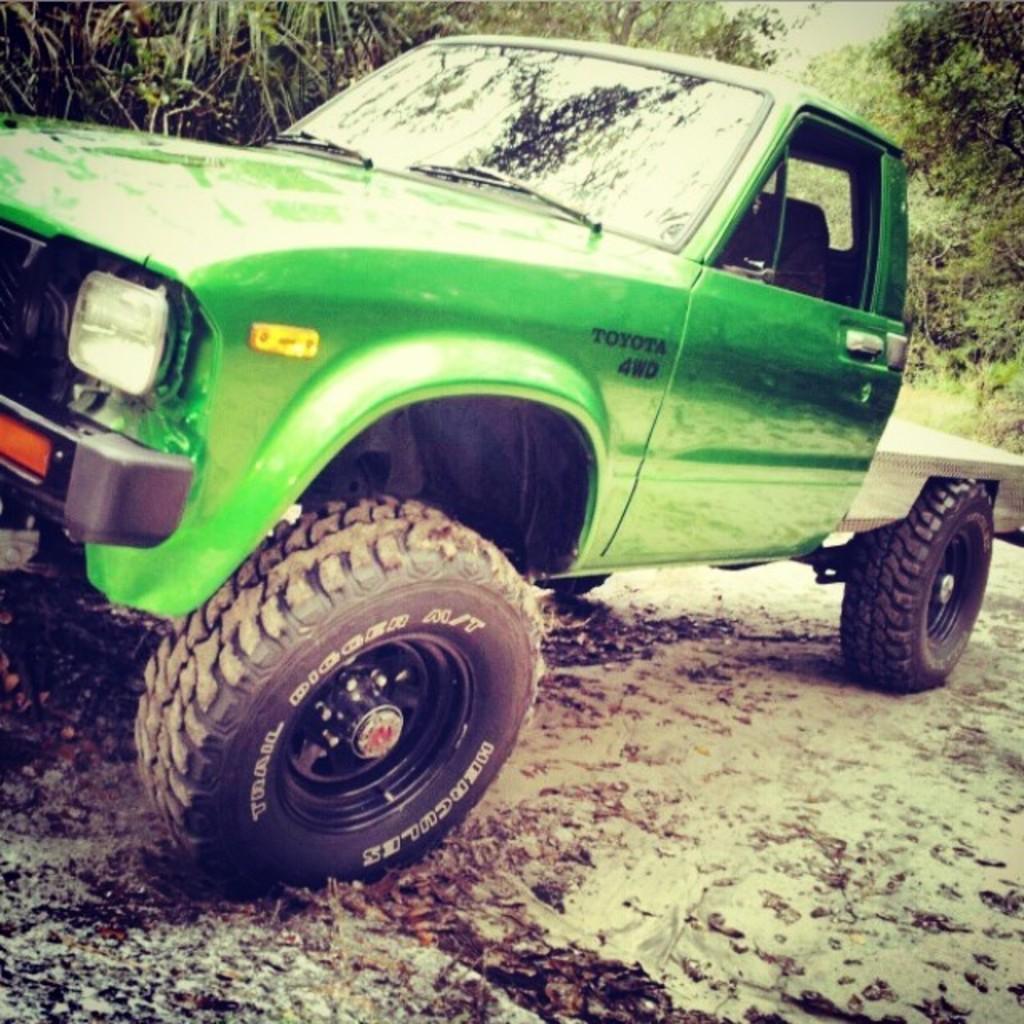Describe this image in one or two sentences. In this image, we can see a green truck on the ground. Background we can see trees. 